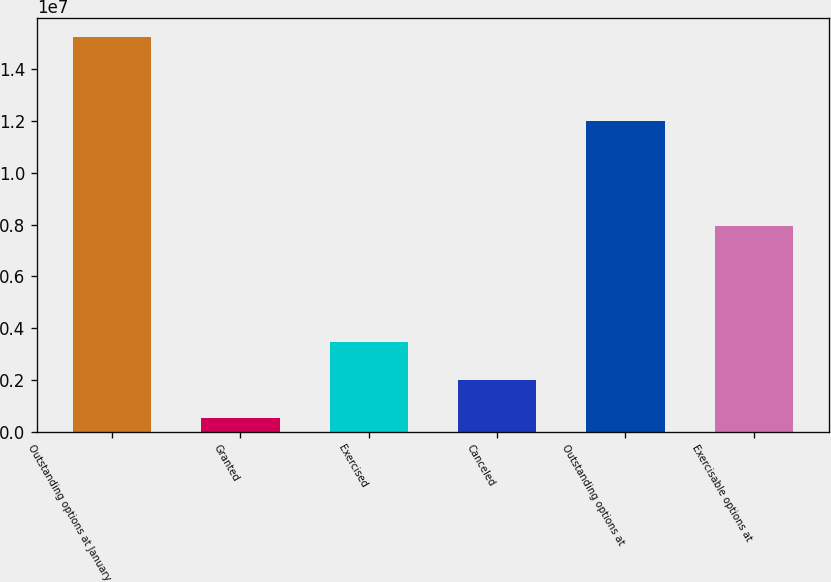<chart> <loc_0><loc_0><loc_500><loc_500><bar_chart><fcel>Outstanding options at January<fcel>Granted<fcel>Exercised<fcel>Canceled<fcel>Outstanding options at<fcel>Exercisable options at<nl><fcel>1.52346e+07<fcel>536991<fcel>3.47651e+06<fcel>2.00675e+06<fcel>1.19945e+07<fcel>7.94928e+06<nl></chart> 